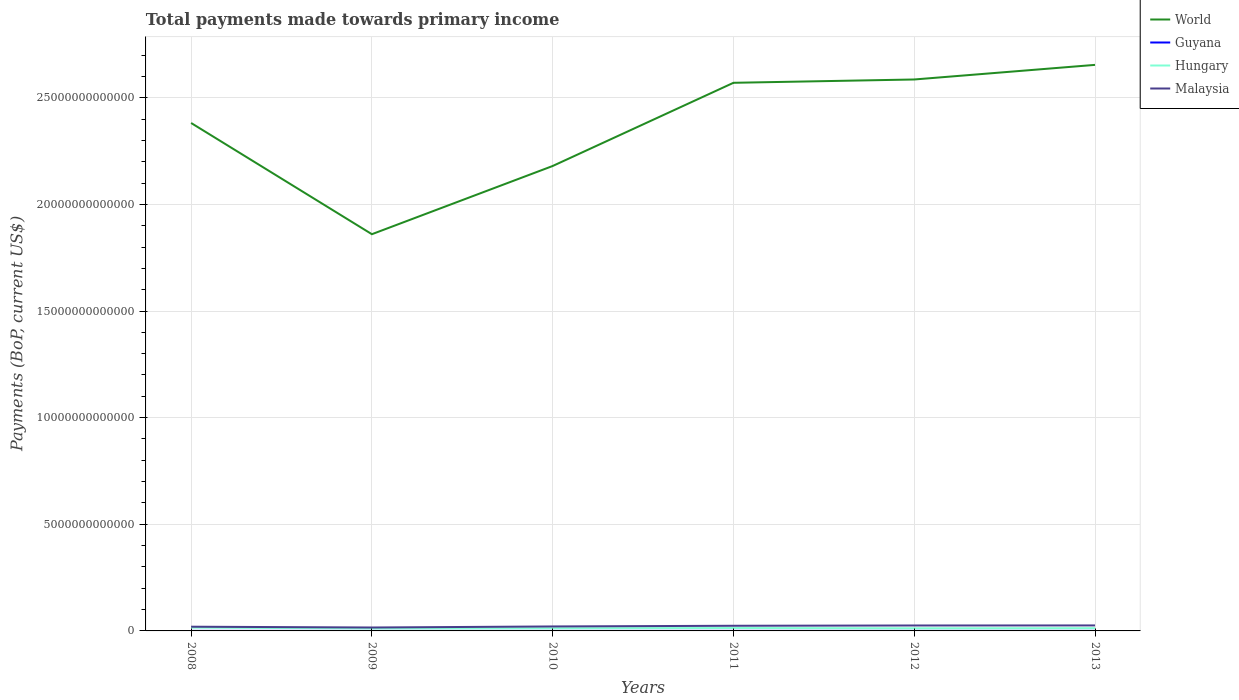How many different coloured lines are there?
Your answer should be very brief. 4. Does the line corresponding to Malaysia intersect with the line corresponding to Hungary?
Make the answer very short. No. Is the number of lines equal to the number of legend labels?
Provide a succinct answer. Yes. Across all years, what is the maximum total payments made towards primary income in Guyana?
Ensure brevity in your answer.  1.51e+09. What is the total total payments made towards primary income in World in the graph?
Your response must be concise. -7.10e+12. What is the difference between the highest and the second highest total payments made towards primary income in Guyana?
Give a very brief answer. 1.04e+09. What is the difference between the highest and the lowest total payments made towards primary income in Hungary?
Give a very brief answer. 2. How many lines are there?
Your answer should be compact. 4. How many years are there in the graph?
Ensure brevity in your answer.  6. What is the difference between two consecutive major ticks on the Y-axis?
Your answer should be compact. 5.00e+12. Are the values on the major ticks of Y-axis written in scientific E-notation?
Ensure brevity in your answer.  No. How many legend labels are there?
Provide a succinct answer. 4. How are the legend labels stacked?
Your answer should be very brief. Vertical. What is the title of the graph?
Give a very brief answer. Total payments made towards primary income. What is the label or title of the X-axis?
Keep it short and to the point. Years. What is the label or title of the Y-axis?
Offer a very short reply. Payments (BoP, current US$). What is the Payments (BoP, current US$) in World in 2008?
Offer a terse response. 2.38e+13. What is the Payments (BoP, current US$) of Guyana in 2008?
Ensure brevity in your answer.  1.70e+09. What is the Payments (BoP, current US$) of Hungary in 2008?
Your answer should be very brief. 1.54e+11. What is the Payments (BoP, current US$) of Malaysia in 2008?
Give a very brief answer. 1.98e+11. What is the Payments (BoP, current US$) of World in 2009?
Give a very brief answer. 1.86e+13. What is the Payments (BoP, current US$) of Guyana in 2009?
Make the answer very short. 1.51e+09. What is the Payments (BoP, current US$) in Hungary in 2009?
Offer a very short reply. 1.17e+11. What is the Payments (BoP, current US$) in Malaysia in 2009?
Give a very brief answer. 1.60e+11. What is the Payments (BoP, current US$) in World in 2010?
Provide a short and direct response. 2.18e+13. What is the Payments (BoP, current US$) of Guyana in 2010?
Ensure brevity in your answer.  1.71e+09. What is the Payments (BoP, current US$) of Hungary in 2010?
Give a very brief answer. 1.26e+11. What is the Payments (BoP, current US$) in Malaysia in 2010?
Provide a short and direct response. 2.10e+11. What is the Payments (BoP, current US$) of World in 2011?
Give a very brief answer. 2.57e+13. What is the Payments (BoP, current US$) of Guyana in 2011?
Your response must be concise. 2.27e+09. What is the Payments (BoP, current US$) in Hungary in 2011?
Give a very brief answer. 1.37e+11. What is the Payments (BoP, current US$) in Malaysia in 2011?
Make the answer very short. 2.42e+11. What is the Payments (BoP, current US$) in World in 2012?
Provide a succinct answer. 2.59e+13. What is the Payments (BoP, current US$) in Guyana in 2012?
Offer a terse response. 2.55e+09. What is the Payments (BoP, current US$) in Hungary in 2012?
Keep it short and to the point. 1.24e+11. What is the Payments (BoP, current US$) of Malaysia in 2012?
Ensure brevity in your answer.  2.55e+11. What is the Payments (BoP, current US$) of World in 2013?
Provide a succinct answer. 2.65e+13. What is the Payments (BoP, current US$) of Guyana in 2013?
Offer a terse response. 2.36e+09. What is the Payments (BoP, current US$) of Hungary in 2013?
Your answer should be compact. 1.29e+11. What is the Payments (BoP, current US$) of Malaysia in 2013?
Your answer should be very brief. 2.57e+11. Across all years, what is the maximum Payments (BoP, current US$) in World?
Provide a short and direct response. 2.65e+13. Across all years, what is the maximum Payments (BoP, current US$) in Guyana?
Keep it short and to the point. 2.55e+09. Across all years, what is the maximum Payments (BoP, current US$) in Hungary?
Your response must be concise. 1.54e+11. Across all years, what is the maximum Payments (BoP, current US$) in Malaysia?
Your answer should be very brief. 2.57e+11. Across all years, what is the minimum Payments (BoP, current US$) of World?
Offer a very short reply. 1.86e+13. Across all years, what is the minimum Payments (BoP, current US$) of Guyana?
Provide a short and direct response. 1.51e+09. Across all years, what is the minimum Payments (BoP, current US$) of Hungary?
Ensure brevity in your answer.  1.17e+11. Across all years, what is the minimum Payments (BoP, current US$) in Malaysia?
Offer a very short reply. 1.60e+11. What is the total Payments (BoP, current US$) of World in the graph?
Make the answer very short. 1.42e+14. What is the total Payments (BoP, current US$) of Guyana in the graph?
Give a very brief answer. 1.21e+1. What is the total Payments (BoP, current US$) of Hungary in the graph?
Provide a short and direct response. 7.86e+11. What is the total Payments (BoP, current US$) of Malaysia in the graph?
Your answer should be very brief. 1.32e+12. What is the difference between the Payments (BoP, current US$) of World in 2008 and that in 2009?
Give a very brief answer. 5.21e+12. What is the difference between the Payments (BoP, current US$) in Guyana in 2008 and that in 2009?
Provide a succinct answer. 1.96e+08. What is the difference between the Payments (BoP, current US$) in Hungary in 2008 and that in 2009?
Your response must be concise. 3.62e+1. What is the difference between the Payments (BoP, current US$) of Malaysia in 2008 and that in 2009?
Provide a short and direct response. 3.77e+1. What is the difference between the Payments (BoP, current US$) in World in 2008 and that in 2010?
Your answer should be compact. 2.02e+12. What is the difference between the Payments (BoP, current US$) in Guyana in 2008 and that in 2010?
Your answer should be very brief. -3.92e+06. What is the difference between the Payments (BoP, current US$) of Hungary in 2008 and that in 2010?
Give a very brief answer. 2.80e+1. What is the difference between the Payments (BoP, current US$) in Malaysia in 2008 and that in 2010?
Make the answer very short. -1.17e+1. What is the difference between the Payments (BoP, current US$) in World in 2008 and that in 2011?
Make the answer very short. -1.88e+12. What is the difference between the Payments (BoP, current US$) in Guyana in 2008 and that in 2011?
Keep it short and to the point. -5.61e+08. What is the difference between the Payments (BoP, current US$) of Hungary in 2008 and that in 2011?
Keep it short and to the point. 1.70e+1. What is the difference between the Payments (BoP, current US$) in Malaysia in 2008 and that in 2011?
Your answer should be compact. -4.36e+1. What is the difference between the Payments (BoP, current US$) in World in 2008 and that in 2012?
Offer a very short reply. -2.04e+12. What is the difference between the Payments (BoP, current US$) of Guyana in 2008 and that in 2012?
Your answer should be compact. -8.45e+08. What is the difference between the Payments (BoP, current US$) of Hungary in 2008 and that in 2012?
Your answer should be very brief. 2.97e+1. What is the difference between the Payments (BoP, current US$) in Malaysia in 2008 and that in 2012?
Offer a terse response. -5.68e+1. What is the difference between the Payments (BoP, current US$) in World in 2008 and that in 2013?
Keep it short and to the point. -2.72e+12. What is the difference between the Payments (BoP, current US$) of Guyana in 2008 and that in 2013?
Give a very brief answer. -6.59e+08. What is the difference between the Payments (BoP, current US$) of Hungary in 2008 and that in 2013?
Provide a succinct answer. 2.45e+1. What is the difference between the Payments (BoP, current US$) of Malaysia in 2008 and that in 2013?
Make the answer very short. -5.96e+1. What is the difference between the Payments (BoP, current US$) of World in 2009 and that in 2010?
Your response must be concise. -3.20e+12. What is the difference between the Payments (BoP, current US$) of Guyana in 2009 and that in 2010?
Your response must be concise. -2.00e+08. What is the difference between the Payments (BoP, current US$) of Hungary in 2009 and that in 2010?
Ensure brevity in your answer.  -8.15e+09. What is the difference between the Payments (BoP, current US$) of Malaysia in 2009 and that in 2010?
Your answer should be compact. -4.94e+1. What is the difference between the Payments (BoP, current US$) of World in 2009 and that in 2011?
Offer a very short reply. -7.10e+12. What is the difference between the Payments (BoP, current US$) in Guyana in 2009 and that in 2011?
Give a very brief answer. -7.57e+08. What is the difference between the Payments (BoP, current US$) in Hungary in 2009 and that in 2011?
Ensure brevity in your answer.  -1.92e+1. What is the difference between the Payments (BoP, current US$) of Malaysia in 2009 and that in 2011?
Make the answer very short. -8.13e+1. What is the difference between the Payments (BoP, current US$) of World in 2009 and that in 2012?
Give a very brief answer. -7.25e+12. What is the difference between the Payments (BoP, current US$) of Guyana in 2009 and that in 2012?
Your response must be concise. -1.04e+09. What is the difference between the Payments (BoP, current US$) of Hungary in 2009 and that in 2012?
Your response must be concise. -6.47e+09. What is the difference between the Payments (BoP, current US$) in Malaysia in 2009 and that in 2012?
Keep it short and to the point. -9.45e+1. What is the difference between the Payments (BoP, current US$) of World in 2009 and that in 2013?
Your answer should be compact. -7.94e+12. What is the difference between the Payments (BoP, current US$) of Guyana in 2009 and that in 2013?
Offer a very short reply. -8.55e+08. What is the difference between the Payments (BoP, current US$) in Hungary in 2009 and that in 2013?
Keep it short and to the point. -1.17e+1. What is the difference between the Payments (BoP, current US$) in Malaysia in 2009 and that in 2013?
Ensure brevity in your answer.  -9.73e+1. What is the difference between the Payments (BoP, current US$) of World in 2010 and that in 2011?
Keep it short and to the point. -3.90e+12. What is the difference between the Payments (BoP, current US$) of Guyana in 2010 and that in 2011?
Ensure brevity in your answer.  -5.57e+08. What is the difference between the Payments (BoP, current US$) in Hungary in 2010 and that in 2011?
Offer a very short reply. -1.11e+1. What is the difference between the Payments (BoP, current US$) in Malaysia in 2010 and that in 2011?
Your answer should be compact. -3.20e+1. What is the difference between the Payments (BoP, current US$) in World in 2010 and that in 2012?
Offer a very short reply. -4.06e+12. What is the difference between the Payments (BoP, current US$) in Guyana in 2010 and that in 2012?
Offer a very short reply. -8.41e+08. What is the difference between the Payments (BoP, current US$) in Hungary in 2010 and that in 2012?
Ensure brevity in your answer.  1.67e+09. What is the difference between the Payments (BoP, current US$) in Malaysia in 2010 and that in 2012?
Your answer should be very brief. -4.52e+1. What is the difference between the Payments (BoP, current US$) of World in 2010 and that in 2013?
Offer a very short reply. -4.74e+12. What is the difference between the Payments (BoP, current US$) in Guyana in 2010 and that in 2013?
Make the answer very short. -6.55e+08. What is the difference between the Payments (BoP, current US$) of Hungary in 2010 and that in 2013?
Give a very brief answer. -3.52e+09. What is the difference between the Payments (BoP, current US$) in Malaysia in 2010 and that in 2013?
Keep it short and to the point. -4.80e+1. What is the difference between the Payments (BoP, current US$) of World in 2011 and that in 2012?
Give a very brief answer. -1.55e+11. What is the difference between the Payments (BoP, current US$) in Guyana in 2011 and that in 2012?
Your answer should be compact. -2.84e+08. What is the difference between the Payments (BoP, current US$) in Hungary in 2011 and that in 2012?
Provide a succinct answer. 1.27e+1. What is the difference between the Payments (BoP, current US$) of Malaysia in 2011 and that in 2012?
Ensure brevity in your answer.  -1.32e+1. What is the difference between the Payments (BoP, current US$) in World in 2011 and that in 2013?
Offer a very short reply. -8.40e+11. What is the difference between the Payments (BoP, current US$) in Guyana in 2011 and that in 2013?
Offer a terse response. -9.81e+07. What is the difference between the Payments (BoP, current US$) of Hungary in 2011 and that in 2013?
Ensure brevity in your answer.  7.55e+09. What is the difference between the Payments (BoP, current US$) of Malaysia in 2011 and that in 2013?
Ensure brevity in your answer.  -1.60e+1. What is the difference between the Payments (BoP, current US$) in World in 2012 and that in 2013?
Offer a very short reply. -6.85e+11. What is the difference between the Payments (BoP, current US$) in Guyana in 2012 and that in 2013?
Ensure brevity in your answer.  1.86e+08. What is the difference between the Payments (BoP, current US$) in Hungary in 2012 and that in 2013?
Your answer should be very brief. -5.20e+09. What is the difference between the Payments (BoP, current US$) in Malaysia in 2012 and that in 2013?
Give a very brief answer. -2.77e+09. What is the difference between the Payments (BoP, current US$) of World in 2008 and the Payments (BoP, current US$) of Guyana in 2009?
Keep it short and to the point. 2.38e+13. What is the difference between the Payments (BoP, current US$) in World in 2008 and the Payments (BoP, current US$) in Hungary in 2009?
Offer a very short reply. 2.37e+13. What is the difference between the Payments (BoP, current US$) in World in 2008 and the Payments (BoP, current US$) in Malaysia in 2009?
Offer a terse response. 2.37e+13. What is the difference between the Payments (BoP, current US$) of Guyana in 2008 and the Payments (BoP, current US$) of Hungary in 2009?
Keep it short and to the point. -1.16e+11. What is the difference between the Payments (BoP, current US$) of Guyana in 2008 and the Payments (BoP, current US$) of Malaysia in 2009?
Your answer should be very brief. -1.58e+11. What is the difference between the Payments (BoP, current US$) of Hungary in 2008 and the Payments (BoP, current US$) of Malaysia in 2009?
Your answer should be very brief. -6.64e+09. What is the difference between the Payments (BoP, current US$) in World in 2008 and the Payments (BoP, current US$) in Guyana in 2010?
Provide a short and direct response. 2.38e+13. What is the difference between the Payments (BoP, current US$) in World in 2008 and the Payments (BoP, current US$) in Hungary in 2010?
Your answer should be compact. 2.37e+13. What is the difference between the Payments (BoP, current US$) in World in 2008 and the Payments (BoP, current US$) in Malaysia in 2010?
Make the answer very short. 2.36e+13. What is the difference between the Payments (BoP, current US$) of Guyana in 2008 and the Payments (BoP, current US$) of Hungary in 2010?
Provide a short and direct response. -1.24e+11. What is the difference between the Payments (BoP, current US$) of Guyana in 2008 and the Payments (BoP, current US$) of Malaysia in 2010?
Keep it short and to the point. -2.08e+11. What is the difference between the Payments (BoP, current US$) in Hungary in 2008 and the Payments (BoP, current US$) in Malaysia in 2010?
Provide a succinct answer. -5.60e+1. What is the difference between the Payments (BoP, current US$) in World in 2008 and the Payments (BoP, current US$) in Guyana in 2011?
Ensure brevity in your answer.  2.38e+13. What is the difference between the Payments (BoP, current US$) of World in 2008 and the Payments (BoP, current US$) of Hungary in 2011?
Your answer should be very brief. 2.37e+13. What is the difference between the Payments (BoP, current US$) in World in 2008 and the Payments (BoP, current US$) in Malaysia in 2011?
Offer a very short reply. 2.36e+13. What is the difference between the Payments (BoP, current US$) of Guyana in 2008 and the Payments (BoP, current US$) of Hungary in 2011?
Your answer should be compact. -1.35e+11. What is the difference between the Payments (BoP, current US$) in Guyana in 2008 and the Payments (BoP, current US$) in Malaysia in 2011?
Your answer should be very brief. -2.40e+11. What is the difference between the Payments (BoP, current US$) in Hungary in 2008 and the Payments (BoP, current US$) in Malaysia in 2011?
Offer a terse response. -8.80e+1. What is the difference between the Payments (BoP, current US$) in World in 2008 and the Payments (BoP, current US$) in Guyana in 2012?
Ensure brevity in your answer.  2.38e+13. What is the difference between the Payments (BoP, current US$) of World in 2008 and the Payments (BoP, current US$) of Hungary in 2012?
Provide a short and direct response. 2.37e+13. What is the difference between the Payments (BoP, current US$) of World in 2008 and the Payments (BoP, current US$) of Malaysia in 2012?
Ensure brevity in your answer.  2.36e+13. What is the difference between the Payments (BoP, current US$) of Guyana in 2008 and the Payments (BoP, current US$) of Hungary in 2012?
Provide a short and direct response. -1.22e+11. What is the difference between the Payments (BoP, current US$) of Guyana in 2008 and the Payments (BoP, current US$) of Malaysia in 2012?
Offer a very short reply. -2.53e+11. What is the difference between the Payments (BoP, current US$) of Hungary in 2008 and the Payments (BoP, current US$) of Malaysia in 2012?
Ensure brevity in your answer.  -1.01e+11. What is the difference between the Payments (BoP, current US$) of World in 2008 and the Payments (BoP, current US$) of Guyana in 2013?
Give a very brief answer. 2.38e+13. What is the difference between the Payments (BoP, current US$) in World in 2008 and the Payments (BoP, current US$) in Hungary in 2013?
Your answer should be compact. 2.37e+13. What is the difference between the Payments (BoP, current US$) in World in 2008 and the Payments (BoP, current US$) in Malaysia in 2013?
Keep it short and to the point. 2.36e+13. What is the difference between the Payments (BoP, current US$) in Guyana in 2008 and the Payments (BoP, current US$) in Hungary in 2013?
Your response must be concise. -1.27e+11. What is the difference between the Payments (BoP, current US$) of Guyana in 2008 and the Payments (BoP, current US$) of Malaysia in 2013?
Make the answer very short. -2.56e+11. What is the difference between the Payments (BoP, current US$) in Hungary in 2008 and the Payments (BoP, current US$) in Malaysia in 2013?
Provide a succinct answer. -1.04e+11. What is the difference between the Payments (BoP, current US$) of World in 2009 and the Payments (BoP, current US$) of Guyana in 2010?
Your answer should be very brief. 1.86e+13. What is the difference between the Payments (BoP, current US$) in World in 2009 and the Payments (BoP, current US$) in Hungary in 2010?
Your answer should be very brief. 1.85e+13. What is the difference between the Payments (BoP, current US$) in World in 2009 and the Payments (BoP, current US$) in Malaysia in 2010?
Ensure brevity in your answer.  1.84e+13. What is the difference between the Payments (BoP, current US$) of Guyana in 2009 and the Payments (BoP, current US$) of Hungary in 2010?
Your answer should be compact. -1.24e+11. What is the difference between the Payments (BoP, current US$) of Guyana in 2009 and the Payments (BoP, current US$) of Malaysia in 2010?
Give a very brief answer. -2.08e+11. What is the difference between the Payments (BoP, current US$) of Hungary in 2009 and the Payments (BoP, current US$) of Malaysia in 2010?
Your answer should be compact. -9.22e+1. What is the difference between the Payments (BoP, current US$) in World in 2009 and the Payments (BoP, current US$) in Guyana in 2011?
Make the answer very short. 1.86e+13. What is the difference between the Payments (BoP, current US$) in World in 2009 and the Payments (BoP, current US$) in Hungary in 2011?
Your answer should be very brief. 1.85e+13. What is the difference between the Payments (BoP, current US$) in World in 2009 and the Payments (BoP, current US$) in Malaysia in 2011?
Your answer should be very brief. 1.84e+13. What is the difference between the Payments (BoP, current US$) of Guyana in 2009 and the Payments (BoP, current US$) of Hungary in 2011?
Provide a short and direct response. -1.35e+11. What is the difference between the Payments (BoP, current US$) of Guyana in 2009 and the Payments (BoP, current US$) of Malaysia in 2011?
Keep it short and to the point. -2.40e+11. What is the difference between the Payments (BoP, current US$) of Hungary in 2009 and the Payments (BoP, current US$) of Malaysia in 2011?
Provide a short and direct response. -1.24e+11. What is the difference between the Payments (BoP, current US$) of World in 2009 and the Payments (BoP, current US$) of Guyana in 2012?
Your answer should be compact. 1.86e+13. What is the difference between the Payments (BoP, current US$) of World in 2009 and the Payments (BoP, current US$) of Hungary in 2012?
Provide a short and direct response. 1.85e+13. What is the difference between the Payments (BoP, current US$) in World in 2009 and the Payments (BoP, current US$) in Malaysia in 2012?
Ensure brevity in your answer.  1.83e+13. What is the difference between the Payments (BoP, current US$) of Guyana in 2009 and the Payments (BoP, current US$) of Hungary in 2012?
Your answer should be very brief. -1.22e+11. What is the difference between the Payments (BoP, current US$) in Guyana in 2009 and the Payments (BoP, current US$) in Malaysia in 2012?
Keep it short and to the point. -2.53e+11. What is the difference between the Payments (BoP, current US$) of Hungary in 2009 and the Payments (BoP, current US$) of Malaysia in 2012?
Ensure brevity in your answer.  -1.37e+11. What is the difference between the Payments (BoP, current US$) of World in 2009 and the Payments (BoP, current US$) of Guyana in 2013?
Give a very brief answer. 1.86e+13. What is the difference between the Payments (BoP, current US$) of World in 2009 and the Payments (BoP, current US$) of Hungary in 2013?
Provide a short and direct response. 1.85e+13. What is the difference between the Payments (BoP, current US$) of World in 2009 and the Payments (BoP, current US$) of Malaysia in 2013?
Ensure brevity in your answer.  1.83e+13. What is the difference between the Payments (BoP, current US$) in Guyana in 2009 and the Payments (BoP, current US$) in Hungary in 2013?
Your answer should be compact. -1.28e+11. What is the difference between the Payments (BoP, current US$) of Guyana in 2009 and the Payments (BoP, current US$) of Malaysia in 2013?
Provide a short and direct response. -2.56e+11. What is the difference between the Payments (BoP, current US$) of Hungary in 2009 and the Payments (BoP, current US$) of Malaysia in 2013?
Ensure brevity in your answer.  -1.40e+11. What is the difference between the Payments (BoP, current US$) in World in 2010 and the Payments (BoP, current US$) in Guyana in 2011?
Your answer should be compact. 2.18e+13. What is the difference between the Payments (BoP, current US$) in World in 2010 and the Payments (BoP, current US$) in Hungary in 2011?
Offer a very short reply. 2.17e+13. What is the difference between the Payments (BoP, current US$) in World in 2010 and the Payments (BoP, current US$) in Malaysia in 2011?
Offer a very short reply. 2.16e+13. What is the difference between the Payments (BoP, current US$) of Guyana in 2010 and the Payments (BoP, current US$) of Hungary in 2011?
Keep it short and to the point. -1.35e+11. What is the difference between the Payments (BoP, current US$) of Guyana in 2010 and the Payments (BoP, current US$) of Malaysia in 2011?
Offer a very short reply. -2.40e+11. What is the difference between the Payments (BoP, current US$) in Hungary in 2010 and the Payments (BoP, current US$) in Malaysia in 2011?
Your response must be concise. -1.16e+11. What is the difference between the Payments (BoP, current US$) of World in 2010 and the Payments (BoP, current US$) of Guyana in 2012?
Provide a succinct answer. 2.18e+13. What is the difference between the Payments (BoP, current US$) in World in 2010 and the Payments (BoP, current US$) in Hungary in 2012?
Your answer should be very brief. 2.17e+13. What is the difference between the Payments (BoP, current US$) of World in 2010 and the Payments (BoP, current US$) of Malaysia in 2012?
Keep it short and to the point. 2.15e+13. What is the difference between the Payments (BoP, current US$) of Guyana in 2010 and the Payments (BoP, current US$) of Hungary in 2012?
Keep it short and to the point. -1.22e+11. What is the difference between the Payments (BoP, current US$) of Guyana in 2010 and the Payments (BoP, current US$) of Malaysia in 2012?
Keep it short and to the point. -2.53e+11. What is the difference between the Payments (BoP, current US$) of Hungary in 2010 and the Payments (BoP, current US$) of Malaysia in 2012?
Offer a very short reply. -1.29e+11. What is the difference between the Payments (BoP, current US$) of World in 2010 and the Payments (BoP, current US$) of Guyana in 2013?
Your answer should be very brief. 2.18e+13. What is the difference between the Payments (BoP, current US$) of World in 2010 and the Payments (BoP, current US$) of Hungary in 2013?
Offer a terse response. 2.17e+13. What is the difference between the Payments (BoP, current US$) of World in 2010 and the Payments (BoP, current US$) of Malaysia in 2013?
Offer a terse response. 2.15e+13. What is the difference between the Payments (BoP, current US$) of Guyana in 2010 and the Payments (BoP, current US$) of Hungary in 2013?
Keep it short and to the point. -1.27e+11. What is the difference between the Payments (BoP, current US$) of Guyana in 2010 and the Payments (BoP, current US$) of Malaysia in 2013?
Give a very brief answer. -2.56e+11. What is the difference between the Payments (BoP, current US$) in Hungary in 2010 and the Payments (BoP, current US$) in Malaysia in 2013?
Your answer should be very brief. -1.32e+11. What is the difference between the Payments (BoP, current US$) in World in 2011 and the Payments (BoP, current US$) in Guyana in 2012?
Your answer should be very brief. 2.57e+13. What is the difference between the Payments (BoP, current US$) of World in 2011 and the Payments (BoP, current US$) of Hungary in 2012?
Your answer should be very brief. 2.56e+13. What is the difference between the Payments (BoP, current US$) of World in 2011 and the Payments (BoP, current US$) of Malaysia in 2012?
Provide a short and direct response. 2.54e+13. What is the difference between the Payments (BoP, current US$) of Guyana in 2011 and the Payments (BoP, current US$) of Hungary in 2012?
Make the answer very short. -1.22e+11. What is the difference between the Payments (BoP, current US$) of Guyana in 2011 and the Payments (BoP, current US$) of Malaysia in 2012?
Your answer should be very brief. -2.52e+11. What is the difference between the Payments (BoP, current US$) in Hungary in 2011 and the Payments (BoP, current US$) in Malaysia in 2012?
Give a very brief answer. -1.18e+11. What is the difference between the Payments (BoP, current US$) in World in 2011 and the Payments (BoP, current US$) in Guyana in 2013?
Provide a short and direct response. 2.57e+13. What is the difference between the Payments (BoP, current US$) in World in 2011 and the Payments (BoP, current US$) in Hungary in 2013?
Make the answer very short. 2.56e+13. What is the difference between the Payments (BoP, current US$) in World in 2011 and the Payments (BoP, current US$) in Malaysia in 2013?
Provide a short and direct response. 2.54e+13. What is the difference between the Payments (BoP, current US$) in Guyana in 2011 and the Payments (BoP, current US$) in Hungary in 2013?
Make the answer very short. -1.27e+11. What is the difference between the Payments (BoP, current US$) in Guyana in 2011 and the Payments (BoP, current US$) in Malaysia in 2013?
Provide a short and direct response. -2.55e+11. What is the difference between the Payments (BoP, current US$) in Hungary in 2011 and the Payments (BoP, current US$) in Malaysia in 2013?
Ensure brevity in your answer.  -1.21e+11. What is the difference between the Payments (BoP, current US$) in World in 2012 and the Payments (BoP, current US$) in Guyana in 2013?
Make the answer very short. 2.59e+13. What is the difference between the Payments (BoP, current US$) in World in 2012 and the Payments (BoP, current US$) in Hungary in 2013?
Your answer should be compact. 2.57e+13. What is the difference between the Payments (BoP, current US$) of World in 2012 and the Payments (BoP, current US$) of Malaysia in 2013?
Provide a succinct answer. 2.56e+13. What is the difference between the Payments (BoP, current US$) of Guyana in 2012 and the Payments (BoP, current US$) of Hungary in 2013?
Make the answer very short. -1.26e+11. What is the difference between the Payments (BoP, current US$) in Guyana in 2012 and the Payments (BoP, current US$) in Malaysia in 2013?
Offer a very short reply. -2.55e+11. What is the difference between the Payments (BoP, current US$) in Hungary in 2012 and the Payments (BoP, current US$) in Malaysia in 2013?
Your answer should be compact. -1.34e+11. What is the average Payments (BoP, current US$) in World per year?
Keep it short and to the point. 2.37e+13. What is the average Payments (BoP, current US$) of Guyana per year?
Your answer should be compact. 2.02e+09. What is the average Payments (BoP, current US$) of Hungary per year?
Offer a terse response. 1.31e+11. What is the average Payments (BoP, current US$) in Malaysia per year?
Provide a succinct answer. 2.20e+11. In the year 2008, what is the difference between the Payments (BoP, current US$) in World and Payments (BoP, current US$) in Guyana?
Offer a terse response. 2.38e+13. In the year 2008, what is the difference between the Payments (BoP, current US$) in World and Payments (BoP, current US$) in Hungary?
Your answer should be compact. 2.37e+13. In the year 2008, what is the difference between the Payments (BoP, current US$) in World and Payments (BoP, current US$) in Malaysia?
Offer a terse response. 2.36e+13. In the year 2008, what is the difference between the Payments (BoP, current US$) in Guyana and Payments (BoP, current US$) in Hungary?
Ensure brevity in your answer.  -1.52e+11. In the year 2008, what is the difference between the Payments (BoP, current US$) of Guyana and Payments (BoP, current US$) of Malaysia?
Your answer should be very brief. -1.96e+11. In the year 2008, what is the difference between the Payments (BoP, current US$) of Hungary and Payments (BoP, current US$) of Malaysia?
Provide a succinct answer. -4.43e+1. In the year 2009, what is the difference between the Payments (BoP, current US$) of World and Payments (BoP, current US$) of Guyana?
Make the answer very short. 1.86e+13. In the year 2009, what is the difference between the Payments (BoP, current US$) in World and Payments (BoP, current US$) in Hungary?
Offer a terse response. 1.85e+13. In the year 2009, what is the difference between the Payments (BoP, current US$) in World and Payments (BoP, current US$) in Malaysia?
Offer a terse response. 1.84e+13. In the year 2009, what is the difference between the Payments (BoP, current US$) in Guyana and Payments (BoP, current US$) in Hungary?
Make the answer very short. -1.16e+11. In the year 2009, what is the difference between the Payments (BoP, current US$) of Guyana and Payments (BoP, current US$) of Malaysia?
Offer a very short reply. -1.59e+11. In the year 2009, what is the difference between the Payments (BoP, current US$) of Hungary and Payments (BoP, current US$) of Malaysia?
Keep it short and to the point. -4.28e+1. In the year 2010, what is the difference between the Payments (BoP, current US$) in World and Payments (BoP, current US$) in Guyana?
Ensure brevity in your answer.  2.18e+13. In the year 2010, what is the difference between the Payments (BoP, current US$) of World and Payments (BoP, current US$) of Hungary?
Offer a very short reply. 2.17e+13. In the year 2010, what is the difference between the Payments (BoP, current US$) of World and Payments (BoP, current US$) of Malaysia?
Your response must be concise. 2.16e+13. In the year 2010, what is the difference between the Payments (BoP, current US$) of Guyana and Payments (BoP, current US$) of Hungary?
Provide a short and direct response. -1.24e+11. In the year 2010, what is the difference between the Payments (BoP, current US$) of Guyana and Payments (BoP, current US$) of Malaysia?
Ensure brevity in your answer.  -2.08e+11. In the year 2010, what is the difference between the Payments (BoP, current US$) in Hungary and Payments (BoP, current US$) in Malaysia?
Keep it short and to the point. -8.40e+1. In the year 2011, what is the difference between the Payments (BoP, current US$) in World and Payments (BoP, current US$) in Guyana?
Your answer should be compact. 2.57e+13. In the year 2011, what is the difference between the Payments (BoP, current US$) in World and Payments (BoP, current US$) in Hungary?
Your response must be concise. 2.56e+13. In the year 2011, what is the difference between the Payments (BoP, current US$) of World and Payments (BoP, current US$) of Malaysia?
Make the answer very short. 2.55e+13. In the year 2011, what is the difference between the Payments (BoP, current US$) of Guyana and Payments (BoP, current US$) of Hungary?
Provide a short and direct response. -1.34e+11. In the year 2011, what is the difference between the Payments (BoP, current US$) in Guyana and Payments (BoP, current US$) in Malaysia?
Make the answer very short. -2.39e+11. In the year 2011, what is the difference between the Payments (BoP, current US$) of Hungary and Payments (BoP, current US$) of Malaysia?
Give a very brief answer. -1.05e+11. In the year 2012, what is the difference between the Payments (BoP, current US$) in World and Payments (BoP, current US$) in Guyana?
Offer a very short reply. 2.59e+13. In the year 2012, what is the difference between the Payments (BoP, current US$) in World and Payments (BoP, current US$) in Hungary?
Keep it short and to the point. 2.57e+13. In the year 2012, what is the difference between the Payments (BoP, current US$) of World and Payments (BoP, current US$) of Malaysia?
Ensure brevity in your answer.  2.56e+13. In the year 2012, what is the difference between the Payments (BoP, current US$) in Guyana and Payments (BoP, current US$) in Hungary?
Keep it short and to the point. -1.21e+11. In the year 2012, what is the difference between the Payments (BoP, current US$) in Guyana and Payments (BoP, current US$) in Malaysia?
Give a very brief answer. -2.52e+11. In the year 2012, what is the difference between the Payments (BoP, current US$) of Hungary and Payments (BoP, current US$) of Malaysia?
Make the answer very short. -1.31e+11. In the year 2013, what is the difference between the Payments (BoP, current US$) in World and Payments (BoP, current US$) in Guyana?
Your answer should be compact. 2.65e+13. In the year 2013, what is the difference between the Payments (BoP, current US$) in World and Payments (BoP, current US$) in Hungary?
Keep it short and to the point. 2.64e+13. In the year 2013, what is the difference between the Payments (BoP, current US$) in World and Payments (BoP, current US$) in Malaysia?
Make the answer very short. 2.63e+13. In the year 2013, what is the difference between the Payments (BoP, current US$) in Guyana and Payments (BoP, current US$) in Hungary?
Offer a terse response. -1.27e+11. In the year 2013, what is the difference between the Payments (BoP, current US$) in Guyana and Payments (BoP, current US$) in Malaysia?
Provide a succinct answer. -2.55e+11. In the year 2013, what is the difference between the Payments (BoP, current US$) in Hungary and Payments (BoP, current US$) in Malaysia?
Provide a short and direct response. -1.28e+11. What is the ratio of the Payments (BoP, current US$) of World in 2008 to that in 2009?
Your answer should be compact. 1.28. What is the ratio of the Payments (BoP, current US$) in Guyana in 2008 to that in 2009?
Ensure brevity in your answer.  1.13. What is the ratio of the Payments (BoP, current US$) of Hungary in 2008 to that in 2009?
Keep it short and to the point. 1.31. What is the ratio of the Payments (BoP, current US$) of Malaysia in 2008 to that in 2009?
Your response must be concise. 1.24. What is the ratio of the Payments (BoP, current US$) in World in 2008 to that in 2010?
Your response must be concise. 1.09. What is the ratio of the Payments (BoP, current US$) of Guyana in 2008 to that in 2010?
Your response must be concise. 1. What is the ratio of the Payments (BoP, current US$) of Hungary in 2008 to that in 2010?
Offer a very short reply. 1.22. What is the ratio of the Payments (BoP, current US$) in World in 2008 to that in 2011?
Your response must be concise. 0.93. What is the ratio of the Payments (BoP, current US$) of Guyana in 2008 to that in 2011?
Make the answer very short. 0.75. What is the ratio of the Payments (BoP, current US$) in Hungary in 2008 to that in 2011?
Your answer should be very brief. 1.12. What is the ratio of the Payments (BoP, current US$) of Malaysia in 2008 to that in 2011?
Ensure brevity in your answer.  0.82. What is the ratio of the Payments (BoP, current US$) of World in 2008 to that in 2012?
Give a very brief answer. 0.92. What is the ratio of the Payments (BoP, current US$) of Guyana in 2008 to that in 2012?
Your response must be concise. 0.67. What is the ratio of the Payments (BoP, current US$) of Hungary in 2008 to that in 2012?
Ensure brevity in your answer.  1.24. What is the ratio of the Payments (BoP, current US$) of Malaysia in 2008 to that in 2012?
Provide a succinct answer. 0.78. What is the ratio of the Payments (BoP, current US$) of World in 2008 to that in 2013?
Give a very brief answer. 0.9. What is the ratio of the Payments (BoP, current US$) of Guyana in 2008 to that in 2013?
Provide a short and direct response. 0.72. What is the ratio of the Payments (BoP, current US$) of Hungary in 2008 to that in 2013?
Your answer should be compact. 1.19. What is the ratio of the Payments (BoP, current US$) in Malaysia in 2008 to that in 2013?
Offer a very short reply. 0.77. What is the ratio of the Payments (BoP, current US$) of World in 2009 to that in 2010?
Offer a terse response. 0.85. What is the ratio of the Payments (BoP, current US$) of Guyana in 2009 to that in 2010?
Offer a very short reply. 0.88. What is the ratio of the Payments (BoP, current US$) in Hungary in 2009 to that in 2010?
Ensure brevity in your answer.  0.94. What is the ratio of the Payments (BoP, current US$) in Malaysia in 2009 to that in 2010?
Offer a terse response. 0.76. What is the ratio of the Payments (BoP, current US$) of World in 2009 to that in 2011?
Your answer should be very brief. 0.72. What is the ratio of the Payments (BoP, current US$) of Guyana in 2009 to that in 2011?
Provide a short and direct response. 0.67. What is the ratio of the Payments (BoP, current US$) in Hungary in 2009 to that in 2011?
Make the answer very short. 0.86. What is the ratio of the Payments (BoP, current US$) in Malaysia in 2009 to that in 2011?
Your response must be concise. 0.66. What is the ratio of the Payments (BoP, current US$) of World in 2009 to that in 2012?
Provide a short and direct response. 0.72. What is the ratio of the Payments (BoP, current US$) in Guyana in 2009 to that in 2012?
Ensure brevity in your answer.  0.59. What is the ratio of the Payments (BoP, current US$) in Hungary in 2009 to that in 2012?
Your response must be concise. 0.95. What is the ratio of the Payments (BoP, current US$) in Malaysia in 2009 to that in 2012?
Provide a succinct answer. 0.63. What is the ratio of the Payments (BoP, current US$) of World in 2009 to that in 2013?
Ensure brevity in your answer.  0.7. What is the ratio of the Payments (BoP, current US$) in Guyana in 2009 to that in 2013?
Offer a very short reply. 0.64. What is the ratio of the Payments (BoP, current US$) in Hungary in 2009 to that in 2013?
Offer a terse response. 0.91. What is the ratio of the Payments (BoP, current US$) in Malaysia in 2009 to that in 2013?
Make the answer very short. 0.62. What is the ratio of the Payments (BoP, current US$) in World in 2010 to that in 2011?
Your answer should be very brief. 0.85. What is the ratio of the Payments (BoP, current US$) of Guyana in 2010 to that in 2011?
Provide a succinct answer. 0.75. What is the ratio of the Payments (BoP, current US$) of Hungary in 2010 to that in 2011?
Make the answer very short. 0.92. What is the ratio of the Payments (BoP, current US$) in Malaysia in 2010 to that in 2011?
Your answer should be compact. 0.87. What is the ratio of the Payments (BoP, current US$) of World in 2010 to that in 2012?
Offer a very short reply. 0.84. What is the ratio of the Payments (BoP, current US$) of Guyana in 2010 to that in 2012?
Ensure brevity in your answer.  0.67. What is the ratio of the Payments (BoP, current US$) in Hungary in 2010 to that in 2012?
Your answer should be very brief. 1.01. What is the ratio of the Payments (BoP, current US$) in Malaysia in 2010 to that in 2012?
Provide a short and direct response. 0.82. What is the ratio of the Payments (BoP, current US$) in World in 2010 to that in 2013?
Offer a terse response. 0.82. What is the ratio of the Payments (BoP, current US$) in Guyana in 2010 to that in 2013?
Make the answer very short. 0.72. What is the ratio of the Payments (BoP, current US$) in Hungary in 2010 to that in 2013?
Offer a terse response. 0.97. What is the ratio of the Payments (BoP, current US$) in Malaysia in 2010 to that in 2013?
Offer a terse response. 0.81. What is the ratio of the Payments (BoP, current US$) of Guyana in 2011 to that in 2012?
Give a very brief answer. 0.89. What is the ratio of the Payments (BoP, current US$) of Hungary in 2011 to that in 2012?
Your answer should be very brief. 1.1. What is the ratio of the Payments (BoP, current US$) in Malaysia in 2011 to that in 2012?
Make the answer very short. 0.95. What is the ratio of the Payments (BoP, current US$) of World in 2011 to that in 2013?
Ensure brevity in your answer.  0.97. What is the ratio of the Payments (BoP, current US$) of Guyana in 2011 to that in 2013?
Keep it short and to the point. 0.96. What is the ratio of the Payments (BoP, current US$) of Hungary in 2011 to that in 2013?
Offer a very short reply. 1.06. What is the ratio of the Payments (BoP, current US$) of Malaysia in 2011 to that in 2013?
Keep it short and to the point. 0.94. What is the ratio of the Payments (BoP, current US$) in World in 2012 to that in 2013?
Offer a terse response. 0.97. What is the ratio of the Payments (BoP, current US$) in Guyana in 2012 to that in 2013?
Your answer should be very brief. 1.08. What is the ratio of the Payments (BoP, current US$) of Hungary in 2012 to that in 2013?
Your answer should be very brief. 0.96. What is the difference between the highest and the second highest Payments (BoP, current US$) of World?
Make the answer very short. 6.85e+11. What is the difference between the highest and the second highest Payments (BoP, current US$) of Guyana?
Keep it short and to the point. 1.86e+08. What is the difference between the highest and the second highest Payments (BoP, current US$) in Hungary?
Your answer should be compact. 1.70e+1. What is the difference between the highest and the second highest Payments (BoP, current US$) of Malaysia?
Your response must be concise. 2.77e+09. What is the difference between the highest and the lowest Payments (BoP, current US$) in World?
Provide a succinct answer. 7.94e+12. What is the difference between the highest and the lowest Payments (BoP, current US$) in Guyana?
Provide a succinct answer. 1.04e+09. What is the difference between the highest and the lowest Payments (BoP, current US$) in Hungary?
Your response must be concise. 3.62e+1. What is the difference between the highest and the lowest Payments (BoP, current US$) in Malaysia?
Provide a short and direct response. 9.73e+1. 